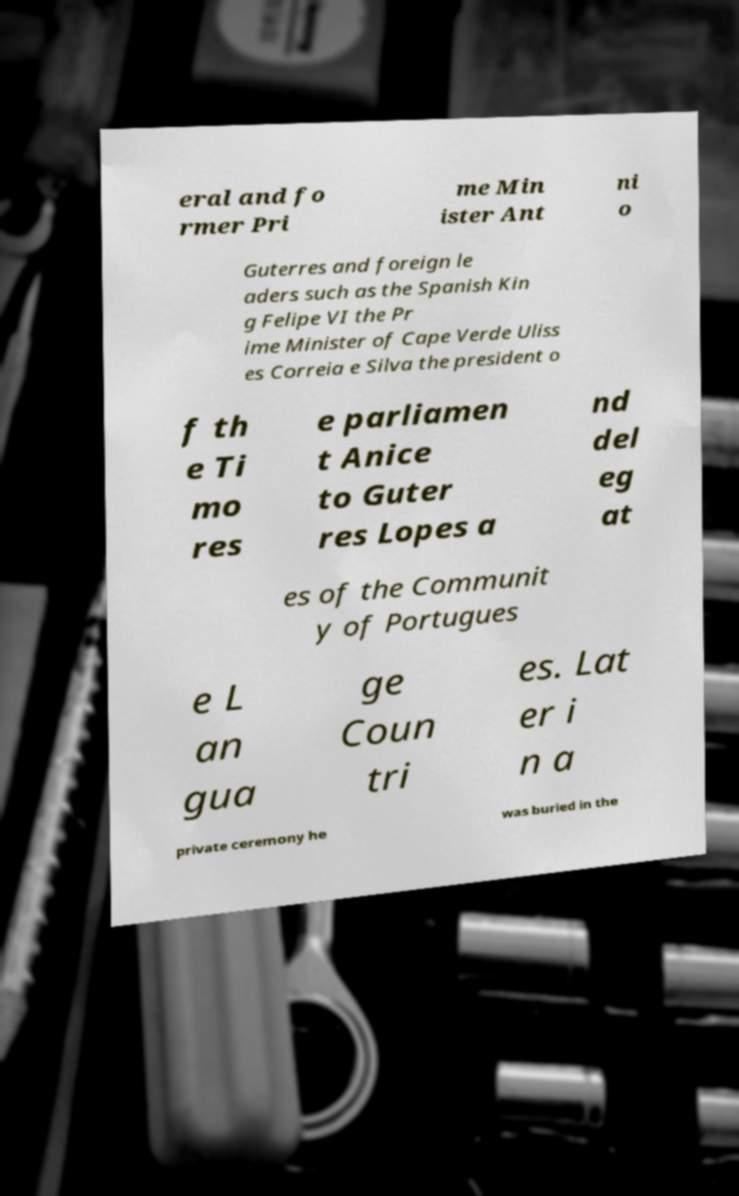Please read and relay the text visible in this image. What does it say? eral and fo rmer Pri me Min ister Ant ni o Guterres and foreign le aders such as the Spanish Kin g Felipe VI the Pr ime Minister of Cape Verde Uliss es Correia e Silva the president o f th e Ti mo res e parliamen t Anice to Guter res Lopes a nd del eg at es of the Communit y of Portugues e L an gua ge Coun tri es. Lat er i n a private ceremony he was buried in the 